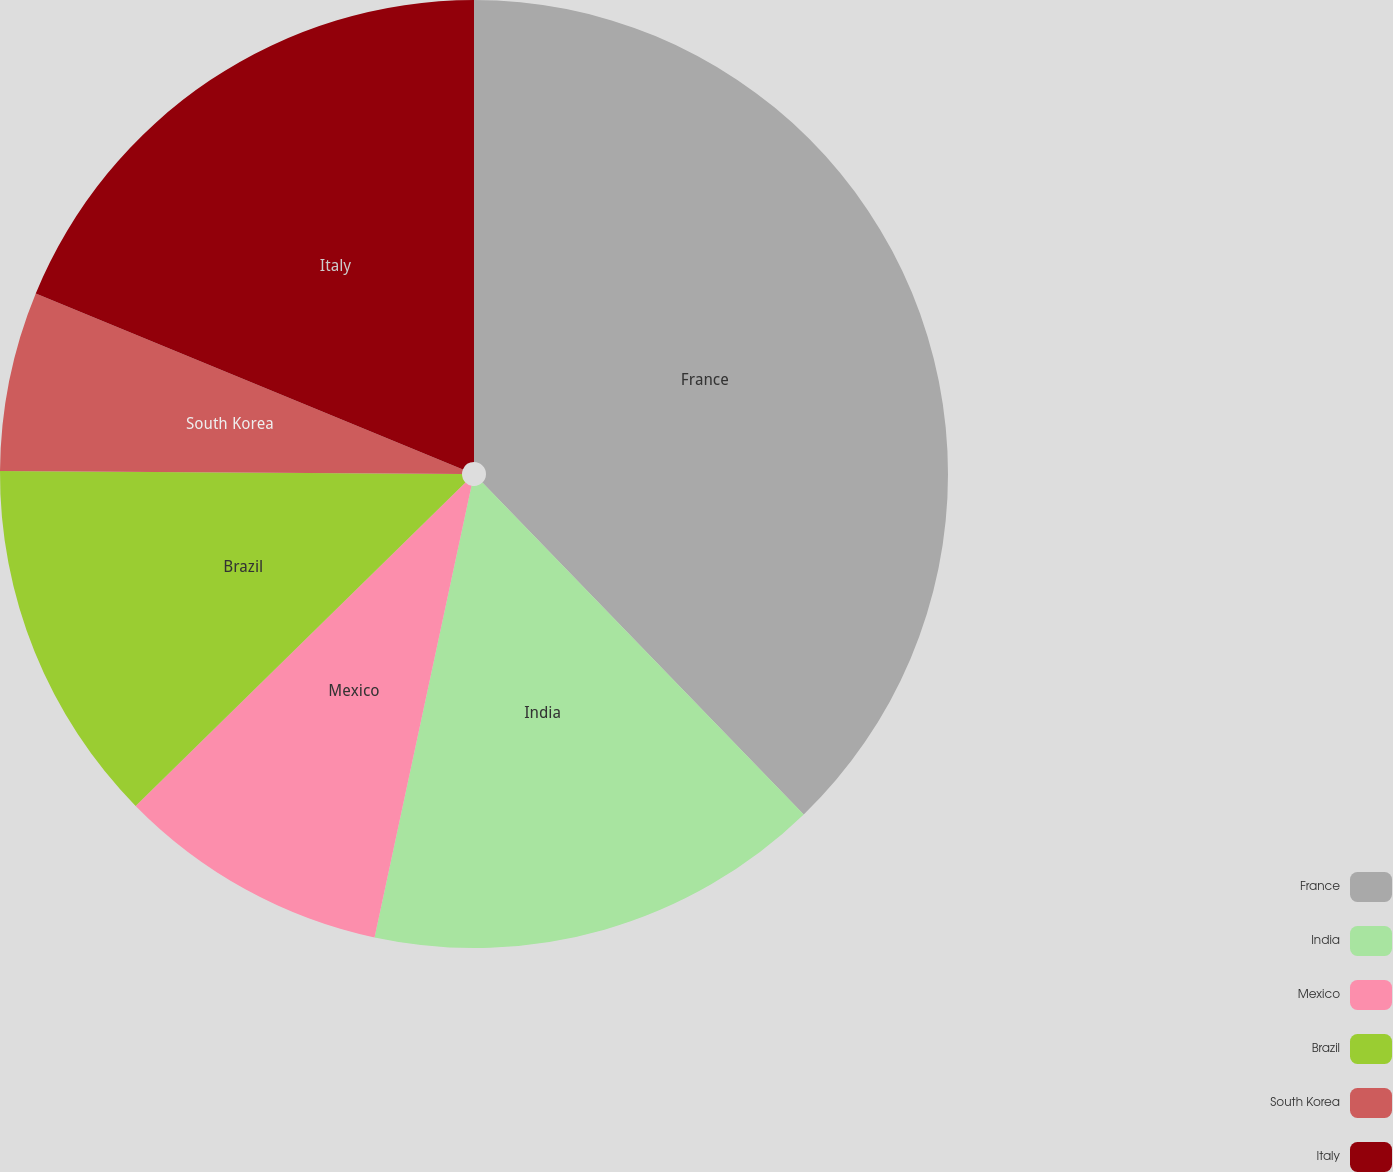Convert chart. <chart><loc_0><loc_0><loc_500><loc_500><pie_chart><fcel>France<fcel>India<fcel>Mexico<fcel>Brazil<fcel>South Korea<fcel>Italy<nl><fcel>37.76%<fcel>15.61%<fcel>9.29%<fcel>12.45%<fcel>6.12%<fcel>18.78%<nl></chart> 